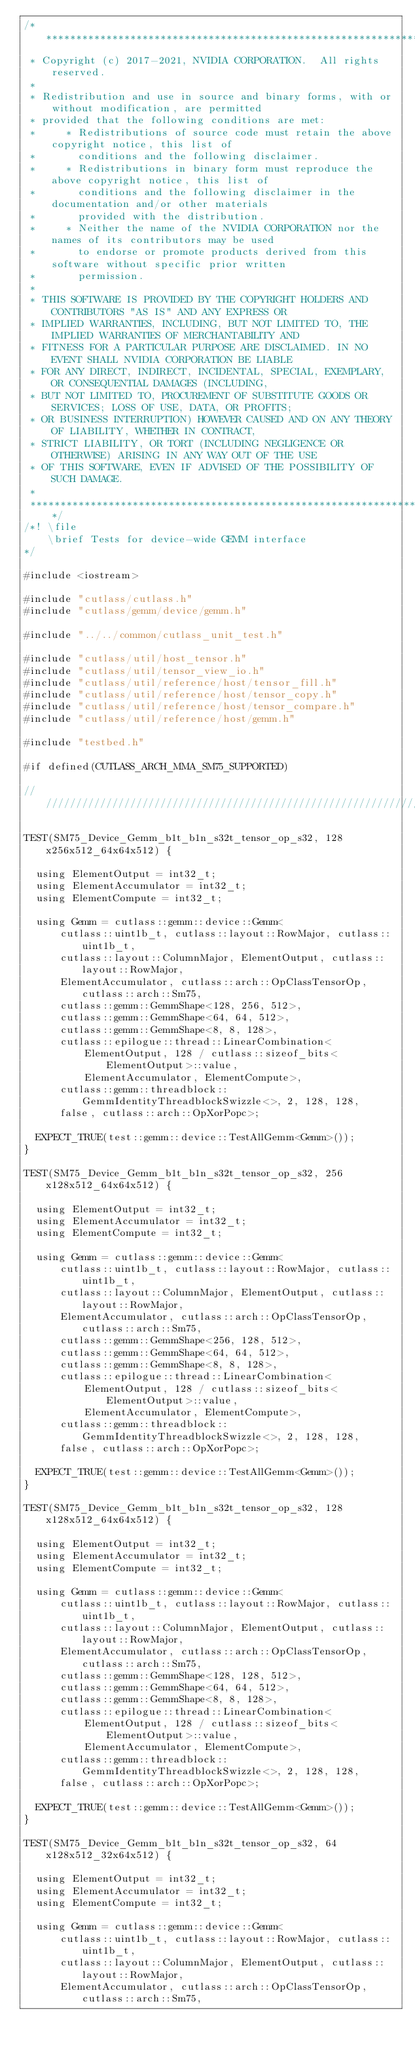<code> <loc_0><loc_0><loc_500><loc_500><_Cuda_>/***************************************************************************************************
 * Copyright (c) 2017-2021, NVIDIA CORPORATION.  All rights reserved.
 *
 * Redistribution and use in source and binary forms, with or without modification, are permitted
 * provided that the following conditions are met:
 *     * Redistributions of source code must retain the above copyright notice, this list of
 *       conditions and the following disclaimer.
 *     * Redistributions in binary form must reproduce the above copyright notice, this list of
 *       conditions and the following disclaimer in the documentation and/or other materials
 *       provided with the distribution.
 *     * Neither the name of the NVIDIA CORPORATION nor the names of its contributors may be used
 *       to endorse or promote products derived from this software without specific prior written
 *       permission.
 *
 * THIS SOFTWARE IS PROVIDED BY THE COPYRIGHT HOLDERS AND CONTRIBUTORS "AS IS" AND ANY EXPRESS OR
 * IMPLIED WARRANTIES, INCLUDING, BUT NOT LIMITED TO, THE IMPLIED WARRANTIES OF MERCHANTABILITY AND
 * FITNESS FOR A PARTICULAR PURPOSE ARE DISCLAIMED. IN NO EVENT SHALL NVIDIA CORPORATION BE LIABLE
 * FOR ANY DIRECT, INDIRECT, INCIDENTAL, SPECIAL, EXEMPLARY, OR CONSEQUENTIAL DAMAGES (INCLUDING,
 * BUT NOT LIMITED TO, PROCUREMENT OF SUBSTITUTE GOODS OR SERVICES; LOSS OF USE, DATA, OR PROFITS;
 * OR BUSINESS INTERRUPTION) HOWEVER CAUSED AND ON ANY THEORY OF LIABILITY, WHETHER IN CONTRACT,
 * STRICT LIABILITY, OR TORT (INCLUDING NEGLIGENCE OR OTHERWISE) ARISING IN ANY WAY OUT OF THE USE
 * OF THIS SOFTWARE, EVEN IF ADVISED OF THE POSSIBILITY OF SUCH DAMAGE.
 *
 **************************************************************************************************/
/*! \file
    \brief Tests for device-wide GEMM interface
*/

#include <iostream>

#include "cutlass/cutlass.h"
#include "cutlass/gemm/device/gemm.h"

#include "../../common/cutlass_unit_test.h"

#include "cutlass/util/host_tensor.h"
#include "cutlass/util/tensor_view_io.h"
#include "cutlass/util/reference/host/tensor_fill.h"
#include "cutlass/util/reference/host/tensor_copy.h"
#include "cutlass/util/reference/host/tensor_compare.h"
#include "cutlass/util/reference/host/gemm.h"

#include "testbed.h"

#if defined(CUTLASS_ARCH_MMA_SM75_SUPPORTED)

/////////////////////////////////////////////////////////////////////////////////////////////////

TEST(SM75_Device_Gemm_b1t_b1n_s32t_tensor_op_s32, 128x256x512_64x64x512) {

  using ElementOutput = int32_t;
  using ElementAccumulator = int32_t;
  using ElementCompute = int32_t;

  using Gemm = cutlass::gemm::device::Gemm<
      cutlass::uint1b_t, cutlass::layout::RowMajor, cutlass::uint1b_t,
      cutlass::layout::ColumnMajor, ElementOutput, cutlass::layout::RowMajor,
      ElementAccumulator, cutlass::arch::OpClassTensorOp, cutlass::arch::Sm75,
      cutlass::gemm::GemmShape<128, 256, 512>,
      cutlass::gemm::GemmShape<64, 64, 512>,
      cutlass::gemm::GemmShape<8, 8, 128>,
      cutlass::epilogue::thread::LinearCombination<
          ElementOutput, 128 / cutlass::sizeof_bits<ElementOutput>::value,
          ElementAccumulator, ElementCompute>,
      cutlass::gemm::threadblock::GemmIdentityThreadblockSwizzle<>, 2, 128, 128,
      false, cutlass::arch::OpXorPopc>;

  EXPECT_TRUE(test::gemm::device::TestAllGemm<Gemm>());
}

TEST(SM75_Device_Gemm_b1t_b1n_s32t_tensor_op_s32, 256x128x512_64x64x512) {

  using ElementOutput = int32_t;
  using ElementAccumulator = int32_t;
  using ElementCompute = int32_t;

  using Gemm = cutlass::gemm::device::Gemm<
      cutlass::uint1b_t, cutlass::layout::RowMajor, cutlass::uint1b_t,
      cutlass::layout::ColumnMajor, ElementOutput, cutlass::layout::RowMajor,
      ElementAccumulator, cutlass::arch::OpClassTensorOp, cutlass::arch::Sm75,
      cutlass::gemm::GemmShape<256, 128, 512>,
      cutlass::gemm::GemmShape<64, 64, 512>,
      cutlass::gemm::GemmShape<8, 8, 128>,
      cutlass::epilogue::thread::LinearCombination<
          ElementOutput, 128 / cutlass::sizeof_bits<ElementOutput>::value,
          ElementAccumulator, ElementCompute>,
      cutlass::gemm::threadblock::GemmIdentityThreadblockSwizzle<>, 2, 128, 128,
      false, cutlass::arch::OpXorPopc>;

  EXPECT_TRUE(test::gemm::device::TestAllGemm<Gemm>());
}

TEST(SM75_Device_Gemm_b1t_b1n_s32t_tensor_op_s32, 128x128x512_64x64x512) {

  using ElementOutput = int32_t;
  using ElementAccumulator = int32_t;
  using ElementCompute = int32_t;

  using Gemm = cutlass::gemm::device::Gemm<
      cutlass::uint1b_t, cutlass::layout::RowMajor, cutlass::uint1b_t,
      cutlass::layout::ColumnMajor, ElementOutput, cutlass::layout::RowMajor,
      ElementAccumulator, cutlass::arch::OpClassTensorOp, cutlass::arch::Sm75,
      cutlass::gemm::GemmShape<128, 128, 512>,
      cutlass::gemm::GemmShape<64, 64, 512>,
      cutlass::gemm::GemmShape<8, 8, 128>,
      cutlass::epilogue::thread::LinearCombination<
          ElementOutput, 128 / cutlass::sizeof_bits<ElementOutput>::value,
          ElementAccumulator, ElementCompute>,
      cutlass::gemm::threadblock::GemmIdentityThreadblockSwizzle<>, 2, 128, 128,
      false, cutlass::arch::OpXorPopc>;

  EXPECT_TRUE(test::gemm::device::TestAllGemm<Gemm>());
}

TEST(SM75_Device_Gemm_b1t_b1n_s32t_tensor_op_s32, 64x128x512_32x64x512) {

  using ElementOutput = int32_t;
  using ElementAccumulator = int32_t;
  using ElementCompute = int32_t;

  using Gemm = cutlass::gemm::device::Gemm<
      cutlass::uint1b_t, cutlass::layout::RowMajor, cutlass::uint1b_t,
      cutlass::layout::ColumnMajor, ElementOutput, cutlass::layout::RowMajor,
      ElementAccumulator, cutlass::arch::OpClassTensorOp, cutlass::arch::Sm75,</code> 